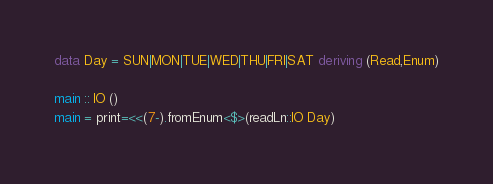Convert code to text. <code><loc_0><loc_0><loc_500><loc_500><_Haskell_>data Day = SUN|MON|TUE|WED|THU|FRI|SAT deriving (Read,Enum)

main :: IO ()
main = print=<<(7-).fromEnum<$>(readLn::IO Day)</code> 